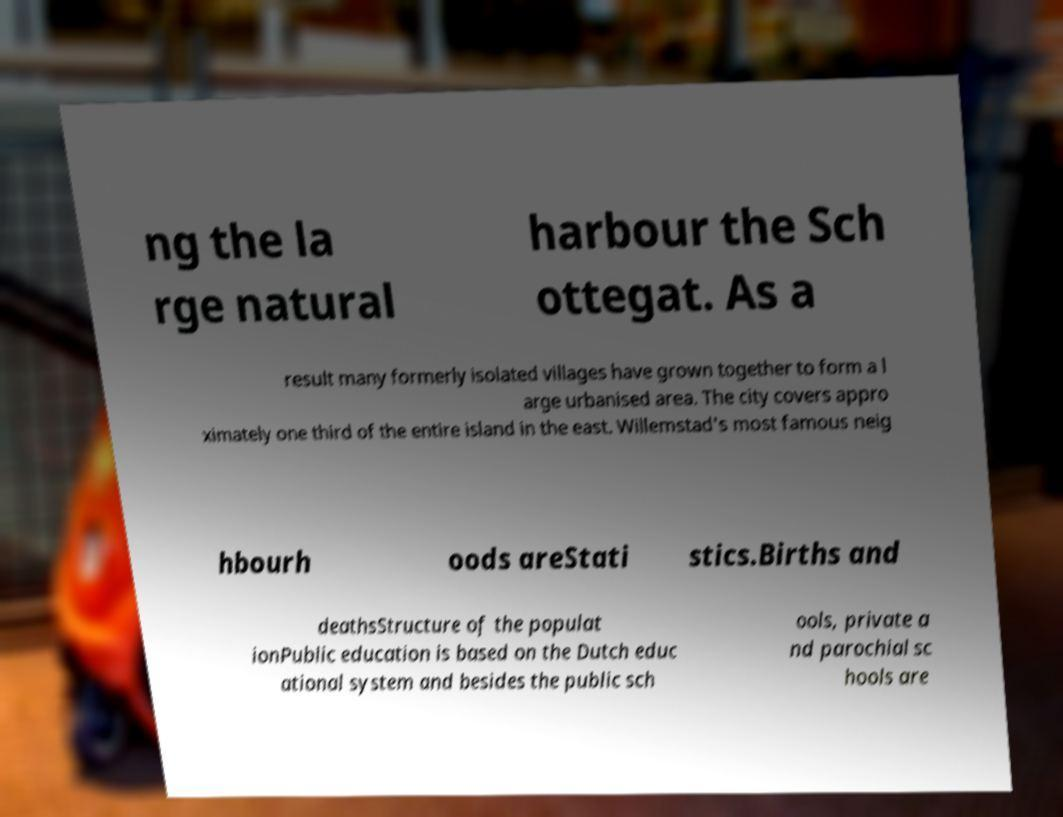For documentation purposes, I need the text within this image transcribed. Could you provide that? ng the la rge natural harbour the Sch ottegat. As a result many formerly isolated villages have grown together to form a l arge urbanised area. The city covers appro ximately one third of the entire island in the east. Willemstad's most famous neig hbourh oods areStati stics.Births and deathsStructure of the populat ionPublic education is based on the Dutch educ ational system and besides the public sch ools, private a nd parochial sc hools are 